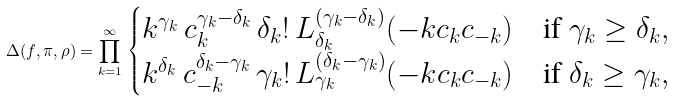Convert formula to latex. <formula><loc_0><loc_0><loc_500><loc_500>\Delta ( f , \pi , \rho ) = \prod _ { k = 1 } ^ { \infty } \, \begin{cases} k ^ { \gamma _ { k } } \, c _ { k } ^ { \gamma _ { k } - \delta _ { k } } \, \delta _ { k } ! \, L _ { \delta _ { k } } ^ { ( \gamma _ { k } - \delta _ { k } ) } ( - k c _ { k } c _ { - k } ) & \text {if $\gamma_{k} \geq \delta_{k}$} , \\ k ^ { \delta _ { k } } \, c _ { - k } ^ { \delta _ { k } - \gamma _ { k } } \, \gamma _ { k } ! \, L _ { \gamma _ { k } } ^ { ( \delta _ { k } - \gamma _ { k } ) } ( - k c _ { k } c _ { - k } ) & \text {if $\delta_{k} \geq \gamma_{k}$} , \end{cases}</formula> 